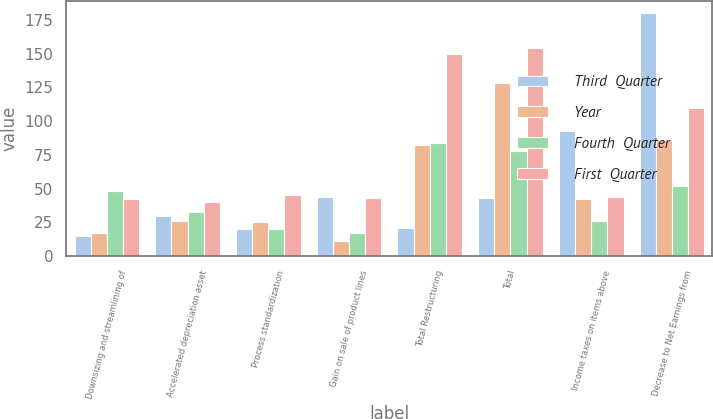Convert chart. <chart><loc_0><loc_0><loc_500><loc_500><stacked_bar_chart><ecel><fcel>Downsizing and streamlining of<fcel>Accelerated depreciation asset<fcel>Process standardization<fcel>Gain on sale of product lines<fcel>Total Restructuring<fcel>Total<fcel>Income taxes on items above<fcel>Decrease to Net Earnings from<nl><fcel>Third  Quarter<fcel>15<fcel>30<fcel>20<fcel>44<fcel>21<fcel>43<fcel>93<fcel>180<nl><fcel>Year<fcel>17<fcel>26<fcel>25<fcel>11<fcel>82<fcel>128<fcel>42<fcel>86<nl><fcel>Fourth  Quarter<fcel>48<fcel>33<fcel>20<fcel>17<fcel>84<fcel>78<fcel>26<fcel>52<nl><fcel>First  Quarter<fcel>42<fcel>40<fcel>45<fcel>43<fcel>150<fcel>154<fcel>44<fcel>110<nl></chart> 